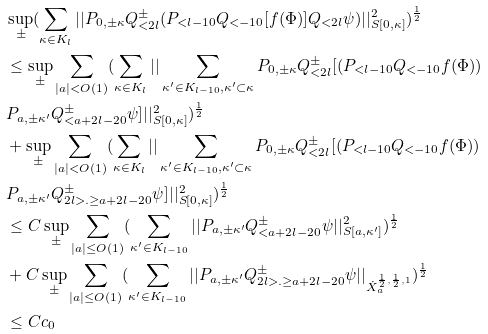<formula> <loc_0><loc_0><loc_500><loc_500>& \sup _ { \pm } ( \sum _ { \kappa \in K _ { l } } | | P _ { 0 , \pm \kappa } Q ^ { \pm } _ { < 2 l } ( P _ { < l - 1 0 } Q _ { < - 1 0 } [ f ( \Phi ) ] Q _ { < 2 l } \psi ) | | _ { S [ 0 , \kappa ] } ^ { 2 } ) ^ { \frac { 1 } { 2 } } \\ & \leq \sup _ { \pm } \sum _ { | a | < O ( 1 ) } ( \sum _ { \kappa \in K _ { l } } | | \sum _ { \kappa ^ { \prime } \in K _ { l - 1 0 } , \kappa ^ { \prime } \subset \kappa } P _ { 0 , \pm \kappa } Q ^ { \pm } _ { < 2 l } [ ( P _ { < l - 1 0 } Q _ { < - 1 0 } f ( \Phi ) ) \\ & P _ { a , \pm \kappa ^ { \prime } } Q ^ { \pm } _ { < a + 2 l - 2 0 } \psi ] | | _ { S [ 0 , \kappa ] } ^ { 2 } ) ^ { \frac { 1 } { 2 } } \\ & + \sup _ { \pm } \sum _ { | a | < O ( 1 ) } ( \sum _ { \kappa \in K _ { l } } | | \sum _ { \kappa ^ { \prime } \in K _ { l - 1 0 } , \kappa ^ { \prime } \subset \kappa } P _ { 0 , \pm \kappa } Q ^ { \pm } _ { < 2 l } [ ( P _ { < l - 1 0 } Q _ { < - 1 0 } f ( \Phi ) ) \\ & P _ { a , \pm \kappa ^ { \prime } } Q ^ { \pm } _ { 2 l > . \geq a + 2 l - 2 0 } \psi ] | | _ { S [ 0 , \kappa ] } ^ { 2 } ) ^ { \frac { 1 } { 2 } } \\ & \leq C \sup _ { \pm } \sum _ { | a | \leq O ( 1 ) } ( \sum _ { \kappa ^ { \prime } \in K _ { l - 1 0 } } | | P _ { a , \pm \kappa ^ { \prime } } Q ^ { \pm } _ { < a + 2 l - 2 0 } \psi | | _ { S [ a , \kappa ^ { \prime } ] } ^ { 2 } ) ^ { \frac { 1 } { 2 } } \\ & + C \sup _ { \pm } \sum _ { | a | \leq O ( 1 ) } ( \sum _ { \kappa ^ { \prime } \in K _ { l - 1 0 } } | | P _ { a , \pm \kappa ^ { \prime } } Q ^ { \pm } _ { 2 l > . \geq a + 2 l - 2 0 } \psi | | _ { \dot { X } _ { a } ^ { \frac { 1 } { 2 } , \frac { 1 } { 2 } , 1 } } ) ^ { \frac { 1 } { 2 } } \\ & \leq C c _ { 0 } \\</formula> 